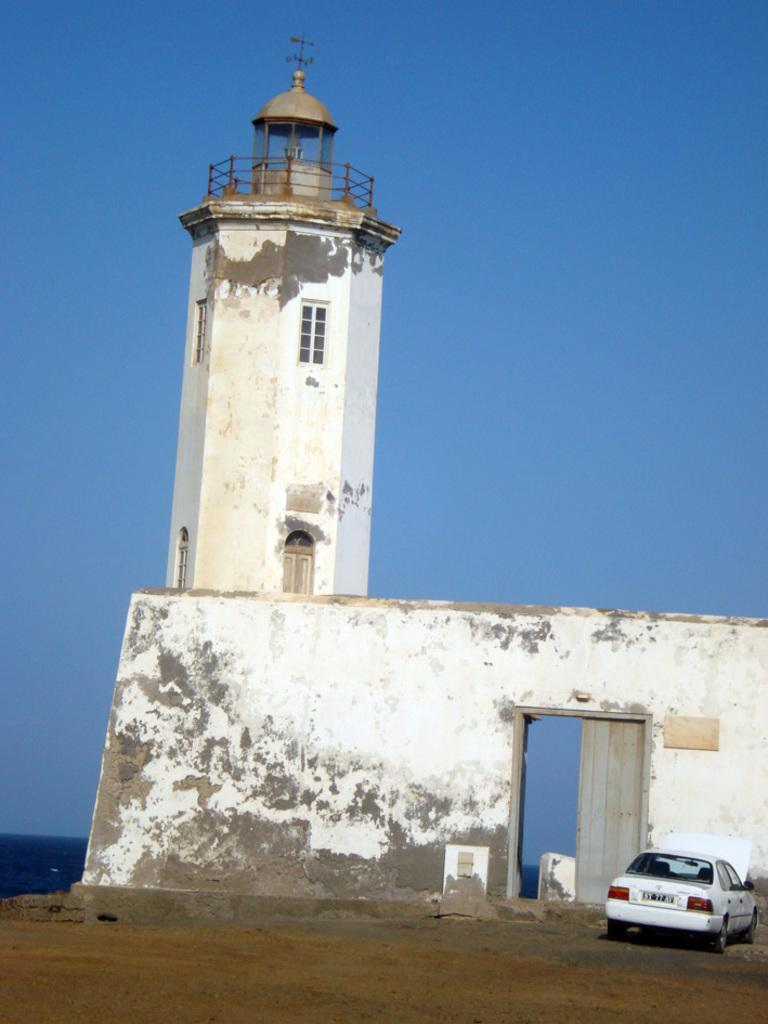What is the main subject of the image? The main subject of the image is a car. Can you describe the car's position in the image? The car is on the ground in the image. What color is the car? The car is white in color. What is in front of the car in the image? There is a wall and a tower in front of the car in the image. What can be seen in the background of the image? The sky is blue in the background of the image. How much brass is visible on the car in the image? There is no brass visible on the car in the image. What type of muscle is being flexed by the car in the image? Cars do not have muscles, so this question is not applicable to the image. 